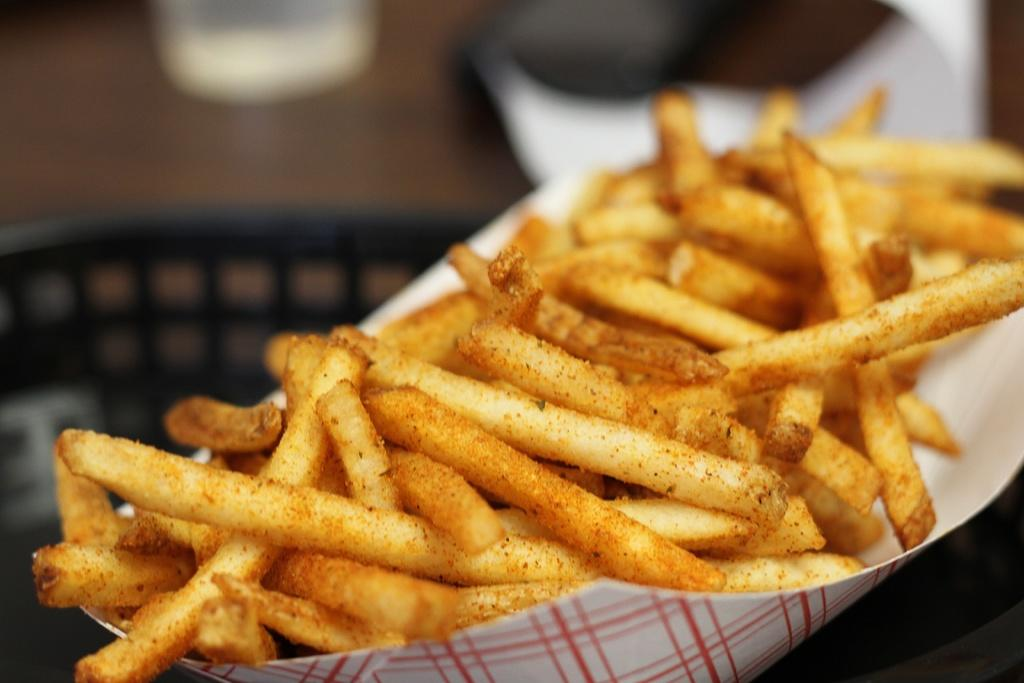What type of food is present in the image? There are french fries in the image. How are the french fries contained in the image? The french fries are in a paper plate. Can you describe the background of the image? The background of the image is blurry. What type of orange can be seen in the background of the image? There is no orange present in the image; the background is blurry. 